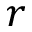<formula> <loc_0><loc_0><loc_500><loc_500>r</formula> 